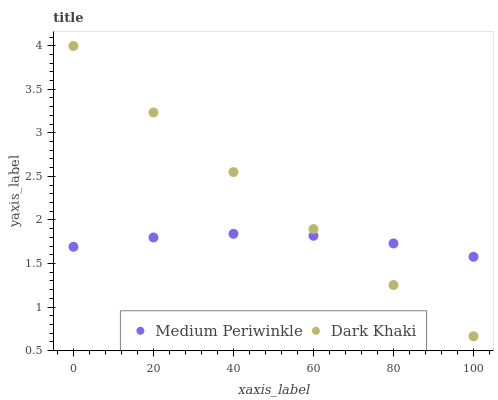Does Medium Periwinkle have the minimum area under the curve?
Answer yes or no. Yes. Does Dark Khaki have the maximum area under the curve?
Answer yes or no. Yes. Does Medium Periwinkle have the maximum area under the curve?
Answer yes or no. No. Is Dark Khaki the smoothest?
Answer yes or no. Yes. Is Medium Periwinkle the roughest?
Answer yes or no. Yes. Is Medium Periwinkle the smoothest?
Answer yes or no. No. Does Dark Khaki have the lowest value?
Answer yes or no. Yes. Does Medium Periwinkle have the lowest value?
Answer yes or no. No. Does Dark Khaki have the highest value?
Answer yes or no. Yes. Does Medium Periwinkle have the highest value?
Answer yes or no. No. Does Medium Periwinkle intersect Dark Khaki?
Answer yes or no. Yes. Is Medium Periwinkle less than Dark Khaki?
Answer yes or no. No. Is Medium Periwinkle greater than Dark Khaki?
Answer yes or no. No. 